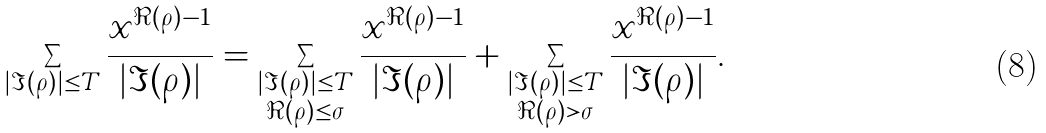<formula> <loc_0><loc_0><loc_500><loc_500>\sum _ { | \Im ( \rho ) | \leq T } \frac { x ^ { \Re ( \rho ) - 1 } } { | \Im ( \rho ) | } = \sum _ { \substack { | \Im ( \rho ) | \leq T \\ \Re ( \rho ) \leq \sigma } } \frac { x ^ { \Re ( \rho ) - 1 } } { | \Im ( \rho ) | } + \sum _ { \substack { | \Im ( \rho ) | \leq T \\ \Re ( \rho ) > \sigma } } \frac { x ^ { \Re ( \rho ) - 1 } } { | \Im ( \rho ) | } .</formula> 